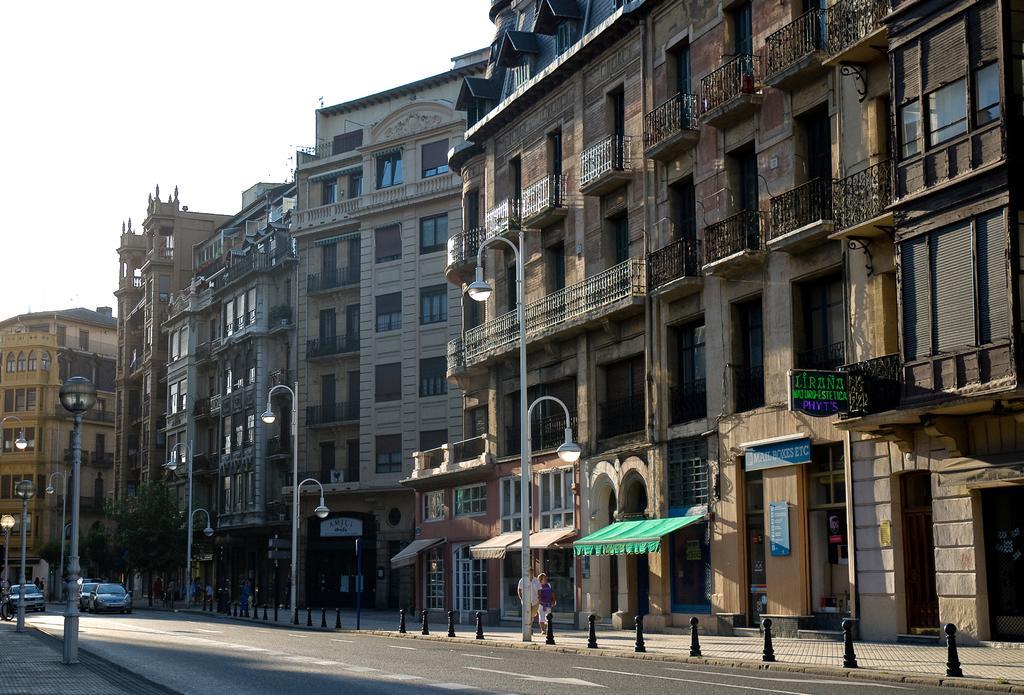In one or two sentences, can you explain what this image depicts? In this picture we can see the buildings, windows, balconies, poles, lights, boards, roofs, trees. At the bottom of the image we can see the road, vehicles and some people are walking on the pavement. At the top of the image we can see the sky. 